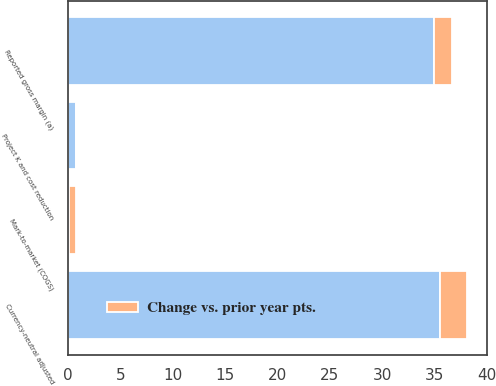Convert chart. <chart><loc_0><loc_0><loc_500><loc_500><stacked_bar_chart><ecel><fcel>Reported gross margin (a)<fcel>Mark-to-market (COGS)<fcel>Project K and cost reduction<fcel>Currency-neutral adjusted<nl><fcel>nan<fcel>34.9<fcel>0.1<fcel>0.8<fcel>35.5<nl><fcel>Change vs. prior year pts.<fcel>1.7<fcel>0.7<fcel>0.1<fcel>2.6<nl></chart> 